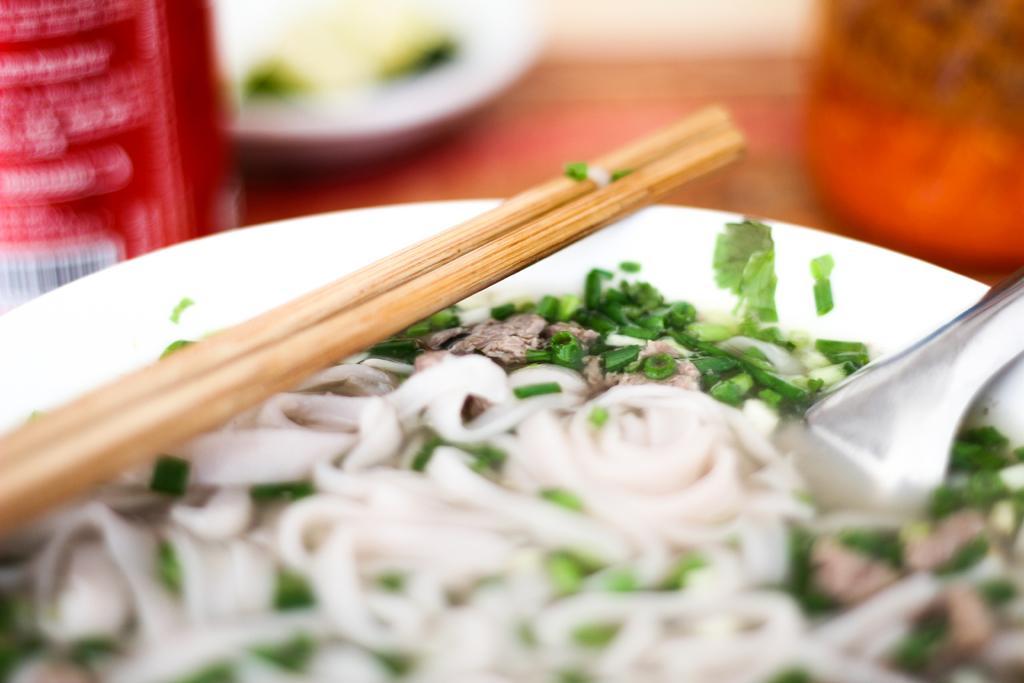How would you summarize this image in a sentence or two? This image consists of a plate, eatables, spoon and chopsticks. This plate is placed on a table. There are some eatables in this plate. 